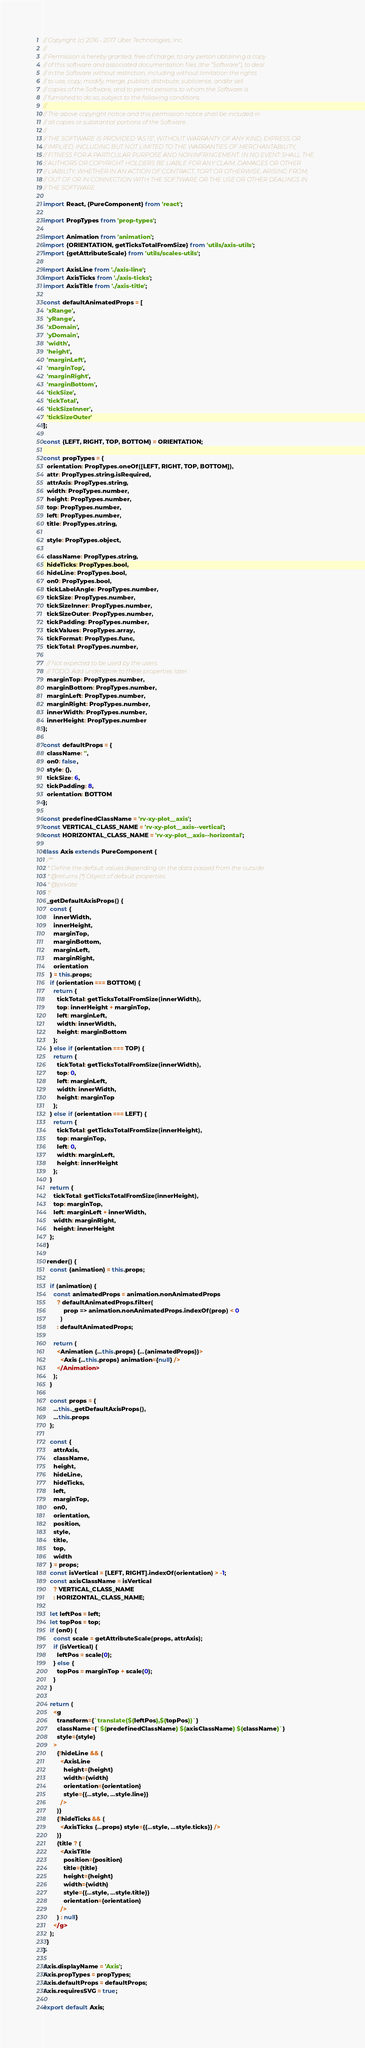Convert code to text. <code><loc_0><loc_0><loc_500><loc_500><_JavaScript_>// Copyright (c) 2016 - 2017 Uber Technologies, Inc.
//
// Permission is hereby granted, free of charge, to any person obtaining a copy
// of this software and associated documentation files (the "Software"), to deal
// in the Software without restriction, including without limitation the rights
// to use, copy, modify, merge, publish, distribute, sublicense, and/or sell
// copies of the Software, and to permit persons to whom the Software is
// furnished to do so, subject to the following conditions:
//
// The above copyright notice and this permission notice shall be included in
// all copies or substantial portions of the Software.
//
// THE SOFTWARE IS PROVIDED "AS IS", WITHOUT WARRANTY OF ANY KIND, EXPRESS OR
// IMPLIED, INCLUDING BUT NOT LIMITED TO THE WARRANTIES OF MERCHANTABILITY,
// FITNESS FOR A PARTICULAR PURPOSE AND NONINFRINGEMENT. IN NO EVENT SHALL THE
// AUTHORS OR COPYRIGHT HOLDERS BE LIABLE FOR ANY CLAIM, DAMAGES OR OTHER
// LIABILITY, WHETHER IN AN ACTION OF CONTRACT, TORT OR OTHERWISE, ARISING FROM,
// OUT OF OR IN CONNECTION WITH THE SOFTWARE OR THE USE OR OTHER DEALINGS IN
// THE SOFTWARE.

import React, {PureComponent} from 'react';

import PropTypes from 'prop-types';

import Animation from 'animation';
import {ORIENTATION, getTicksTotalFromSize} from 'utils/axis-utils';
import {getAttributeScale} from 'utils/scales-utils';

import AxisLine from './axis-line';
import AxisTicks from './axis-ticks';
import AxisTitle from './axis-title';

const defaultAnimatedProps = [
  'xRange',
  'yRange',
  'xDomain',
  'yDomain',
  'width',
  'height',
  'marginLeft',
  'marginTop',
  'marginRight',
  'marginBottom',
  'tickSize',
  'tickTotal',
  'tickSizeInner',
  'tickSizeOuter'
];

const {LEFT, RIGHT, TOP, BOTTOM} = ORIENTATION;

const propTypes = {
  orientation: PropTypes.oneOf([LEFT, RIGHT, TOP, BOTTOM]),
  attr: PropTypes.string.isRequired,
  attrAxis: PropTypes.string,
  width: PropTypes.number,
  height: PropTypes.number,
  top: PropTypes.number,
  left: PropTypes.number,
  title: PropTypes.string,

  style: PropTypes.object,

  className: PropTypes.string,
  hideTicks: PropTypes.bool,
  hideLine: PropTypes.bool,
  on0: PropTypes.bool,
  tickLabelAngle: PropTypes.number,
  tickSize: PropTypes.number,
  tickSizeInner: PropTypes.number,
  tickSizeOuter: PropTypes.number,
  tickPadding: PropTypes.number,
  tickValues: PropTypes.array,
  tickFormat: PropTypes.func,
  tickTotal: PropTypes.number,

  // Not expected to be used by the users.
  // TODO: Add underscore to these properties later.
  marginTop: PropTypes.number,
  marginBottom: PropTypes.number,
  marginLeft: PropTypes.number,
  marginRight: PropTypes.number,
  innerWidth: PropTypes.number,
  innerHeight: PropTypes.number
};

const defaultProps = {
  className: '',
  on0: false,
  style: {},
  tickSize: 6,
  tickPadding: 8,
  orientation: BOTTOM
};

const predefinedClassName = 'rv-xy-plot__axis';
const VERTICAL_CLASS_NAME = 'rv-xy-plot__axis--vertical';
const HORIZONTAL_CLASS_NAME = 'rv-xy-plot__axis--horizontal';

class Axis extends PureComponent {
  /**
   * Define the default values depending on the data passed from the outside.
   * @returns {*} Object of default properties.
   * @private
   */
  _getDefaultAxisProps() {
    const {
      innerWidth,
      innerHeight,
      marginTop,
      marginBottom,
      marginLeft,
      marginRight,
      orientation
    } = this.props;
    if (orientation === BOTTOM) {
      return {
        tickTotal: getTicksTotalFromSize(innerWidth),
        top: innerHeight + marginTop,
        left: marginLeft,
        width: innerWidth,
        height: marginBottom
      };
    } else if (orientation === TOP) {
      return {
        tickTotal: getTicksTotalFromSize(innerWidth),
        top: 0,
        left: marginLeft,
        width: innerWidth,
        height: marginTop
      };
    } else if (orientation === LEFT) {
      return {
        tickTotal: getTicksTotalFromSize(innerHeight),
        top: marginTop,
        left: 0,
        width: marginLeft,
        height: innerHeight
      };
    }
    return {
      tickTotal: getTicksTotalFromSize(innerHeight),
      top: marginTop,
      left: marginLeft + innerWidth,
      width: marginRight,
      height: innerHeight
    };
  }

  render() {
    const {animation} = this.props;

    if (animation) {
      const animatedProps = animation.nonAnimatedProps
        ? defaultAnimatedProps.filter(
            prop => animation.nonAnimatedProps.indexOf(prop) < 0
          )
        : defaultAnimatedProps;

      return (
        <Animation {...this.props} {...{animatedProps}}>
          <Axis {...this.props} animation={null} />
        </Animation>
      );
    }

    const props = {
      ...this._getDefaultAxisProps(),
      ...this.props
    };

    const {
      attrAxis,
      className,
      height,
      hideLine,
      hideTicks,
      left,
      marginTop,
      on0,
      orientation,
      position,
      style,
      title,
      top,
      width
    } = props;
    const isVertical = [LEFT, RIGHT].indexOf(orientation) > -1;
    const axisClassName = isVertical
      ? VERTICAL_CLASS_NAME
      : HORIZONTAL_CLASS_NAME;

    let leftPos = left;
    let topPos = top;
    if (on0) {
      const scale = getAttributeScale(props, attrAxis);
      if (isVertical) {
        leftPos = scale(0);
      } else {
        topPos = marginTop + scale(0);
      }
    }

    return (
      <g
        transform={`translate(${leftPos},${topPos})`}
        className={`${predefinedClassName} ${axisClassName} ${className}`}
        style={style}
      >
        {!hideLine && (
          <AxisLine
            height={height}
            width={width}
            orientation={orientation}
            style={{...style, ...style.line}}
          />
        )}
        {!hideTicks && (
          <AxisTicks {...props} style={{...style, ...style.ticks}} />
        )}
        {title ? (
          <AxisTitle
            position={position}
            title={title}
            height={height}
            width={width}
            style={{...style, ...style.title}}
            orientation={orientation}
          />
        ) : null}
      </g>
    );
  }
}

Axis.displayName = 'Axis';
Axis.propTypes = propTypes;
Axis.defaultProps = defaultProps;
Axis.requiresSVG = true;

export default Axis;
</code> 